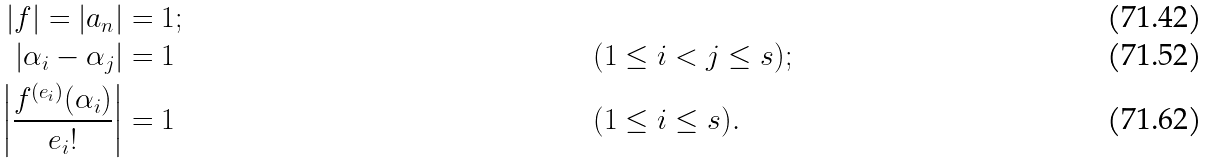Convert formula to latex. <formula><loc_0><loc_0><loc_500><loc_500>| f | = | a _ { n } | & = 1 ; \\ | \alpha _ { i } - \alpha _ { j } | & = 1 & & ( 1 \leq i < j \leq s ) ; \\ \left | \frac { f ^ { ( e _ { i } ) } ( \alpha _ { i } ) } { e _ { i } ! } \right | & = 1 & & ( 1 \leq i \leq s ) .</formula> 